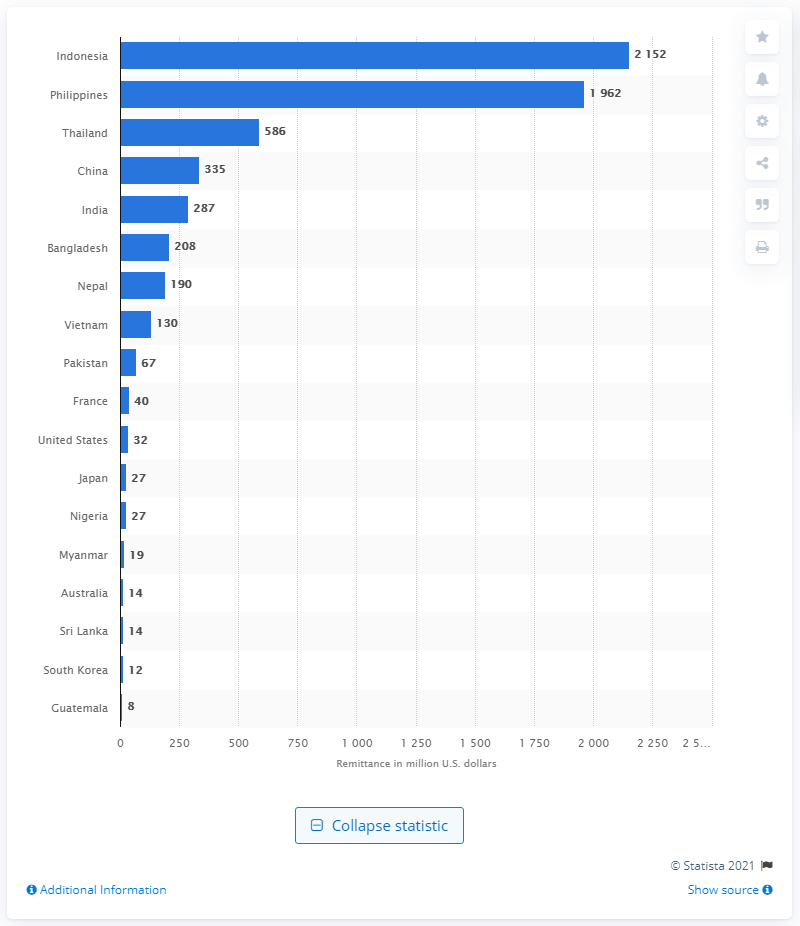Mention a couple of crucial points in this snapshot. In 2017, the amount of dollars that people in Malaysia transferred to Indonesia was 2,152. 